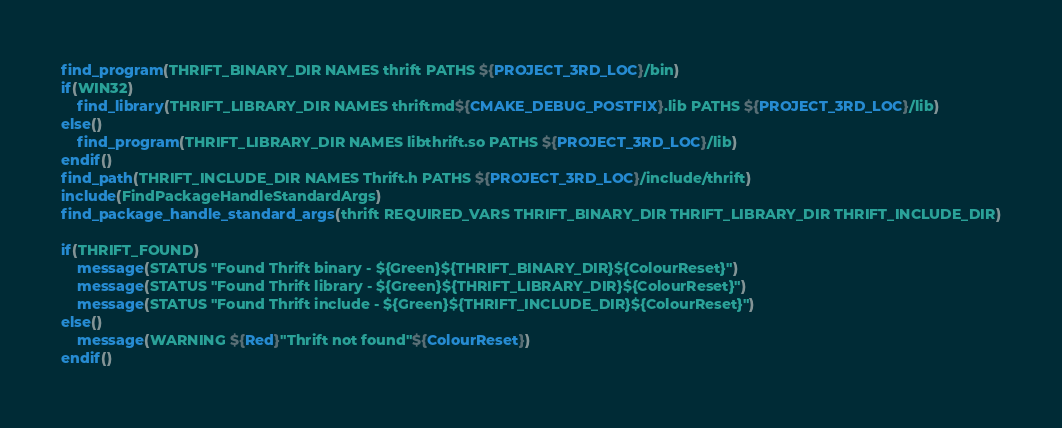Convert code to text. <code><loc_0><loc_0><loc_500><loc_500><_CMake_>find_program(THRIFT_BINARY_DIR NAMES thrift PATHS ${PROJECT_3RD_LOC}/bin)
if(WIN32)
	find_library(THRIFT_LIBRARY_DIR NAMES thriftmd${CMAKE_DEBUG_POSTFIX}.lib PATHS ${PROJECT_3RD_LOC}/lib)
else()
	find_program(THRIFT_LIBRARY_DIR NAMES libthrift.so PATHS ${PROJECT_3RD_LOC}/lib)
endif()	
find_path(THRIFT_INCLUDE_DIR NAMES Thrift.h PATHS ${PROJECT_3RD_LOC}/include/thrift)
include(FindPackageHandleStandardArgs)
find_package_handle_standard_args(thrift REQUIRED_VARS THRIFT_BINARY_DIR THRIFT_LIBRARY_DIR THRIFT_INCLUDE_DIR)

if(THRIFT_FOUND)
    message(STATUS "Found Thrift binary - ${Green}${THRIFT_BINARY_DIR}${ColourReset}")
    message(STATUS "Found Thrift library - ${Green}${THRIFT_LIBRARY_DIR}${ColourReset}")
    message(STATUS "Found Thrift include - ${Green}${THRIFT_INCLUDE_DIR}${ColourReset}")
else()
    message(WARNING ${Red}"Thrift not found"${ColourReset})
endif()
</code> 